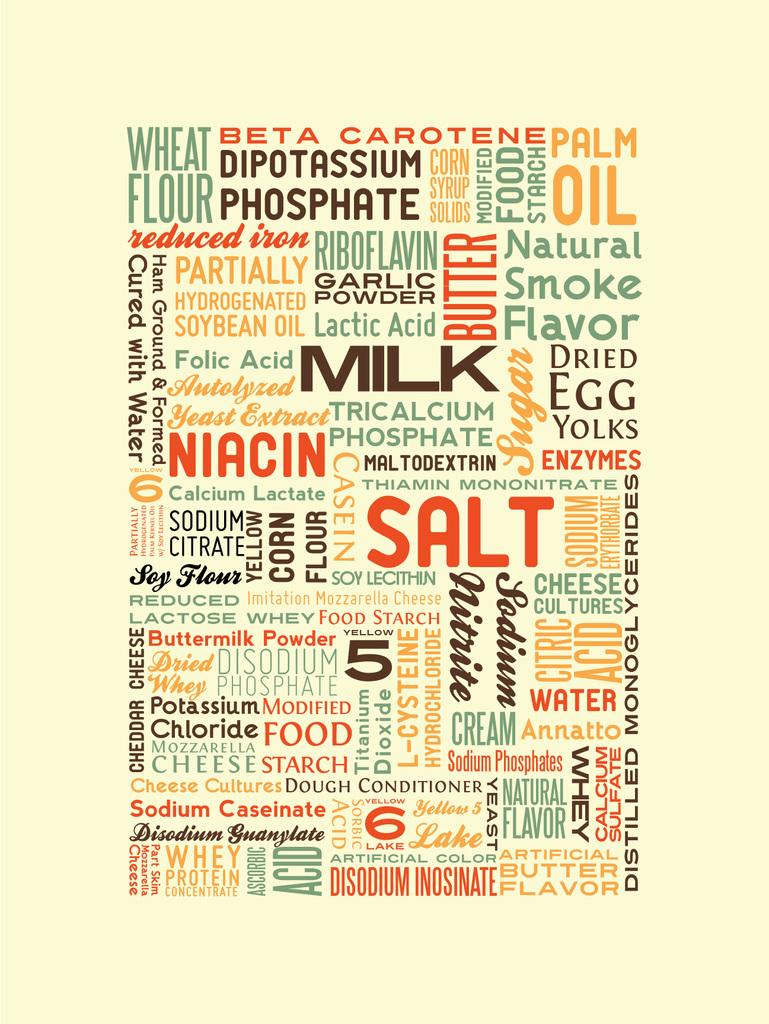<image>
Describe the image concisely. A piece of artwork that has different food words written all over it. 